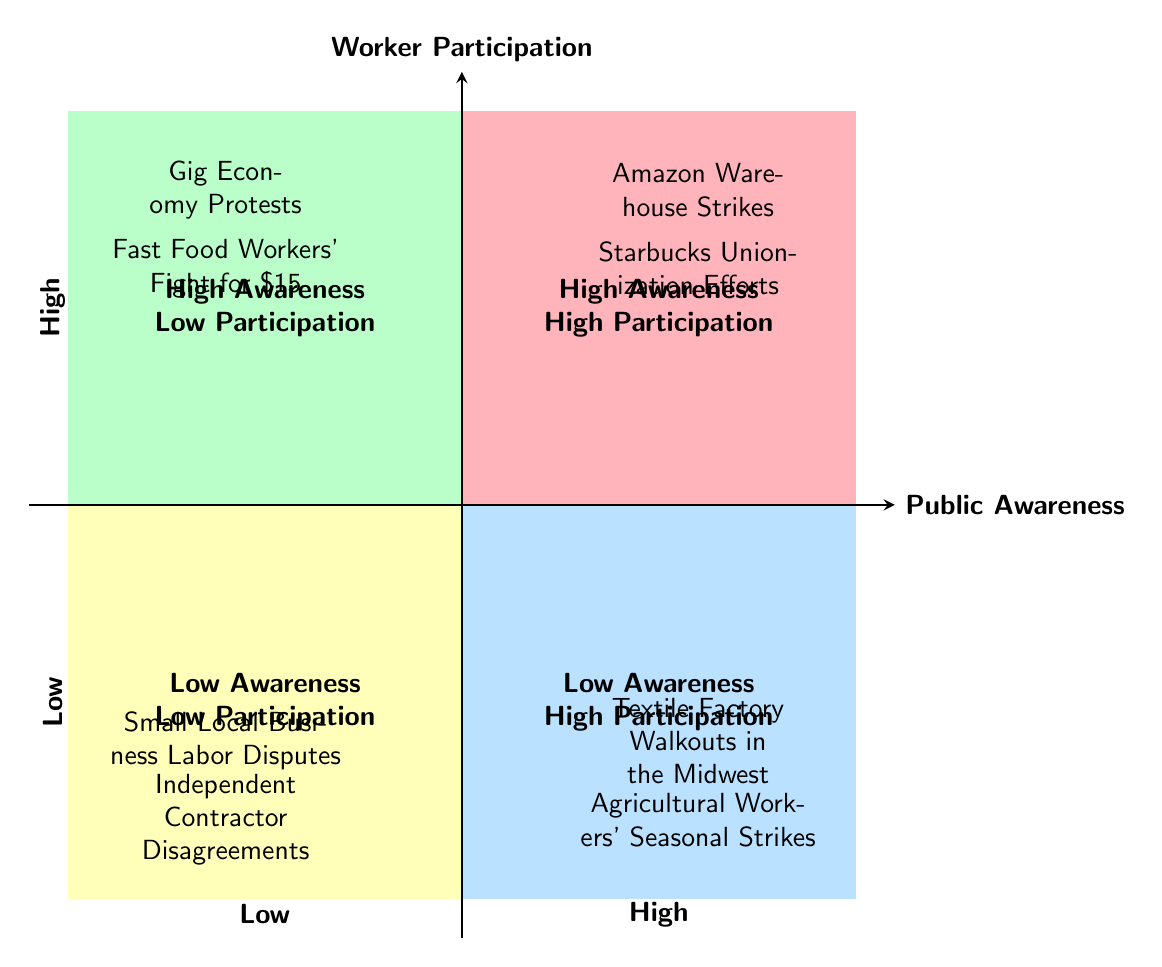What are the two issues featured in Quadrant 1? The diagram shows two issues in Quadrant 1: "Amazon Warehouse Strikes" and "Starbucks Unionization Efforts," which both represent high public awareness and high worker participation.
Answer: Amazon Warehouse Strikes, Starbucks Unionization Efforts Which quadrant contains "Fast Food Workers' Fight for $15"? The visual representation indicates that "Fast Food Workers' Fight for $15" is in Quadrant 2, which has high public awareness but low worker participation.
Answer: Quadrant 2 How many issues are listed in Quadrant 3? Quadrant 3 is detailed with two issues: "Textile Factory Walkouts in the Midwest" and "Agricultural Workers' Seasonal Strikes," indicating low public awareness but high worker participation.
Answer: 2 Compare the number of issues in Quadrant 1 and Quadrant 4. Quadrant 1 has two issues while Quadrant 4 holds two issues as well "Small Local Business Labor Disputes" and "Independent Contractor Disagreements," making them equal in quantity.
Answer: Equal In which quadrant do you find low worker participation? Quadrant 2 and Quadrant 4 both show low worker participation: Quadrant 2 (high awareness, low participation) and Quadrant 4 (low awareness, low participation).
Answer: Quadrant 2, Quadrant 4 Which quadrant is characterized by high public awareness but low worker participation? Quadrant 2 is characterized by high public awareness with low worker participation represented by the provided issues listed there.
Answer: Quadrant 2 What do the two issues in Quadrant 4 signify? The two issues listed in Quadrant 4, "Small Local Business Labor Disputes" and "Independent Contractor Disagreements," signify both low public awareness and low worker participation.
Answer: Low awareness, low participation How are "Textile Factory Walkouts in the Midwest" and "Agricultural Workers' Seasonal Strikes" related? Both issues are located in Quadrant 3, signifying low public awareness yet high worker participation in those movements.
Answer: Low awareness, high participation How many total issues are depicted in the diagram? Adding all the issues across the four quadrants, there are eight total: two in each quadrant as indicated in the representation.
Answer: 8 